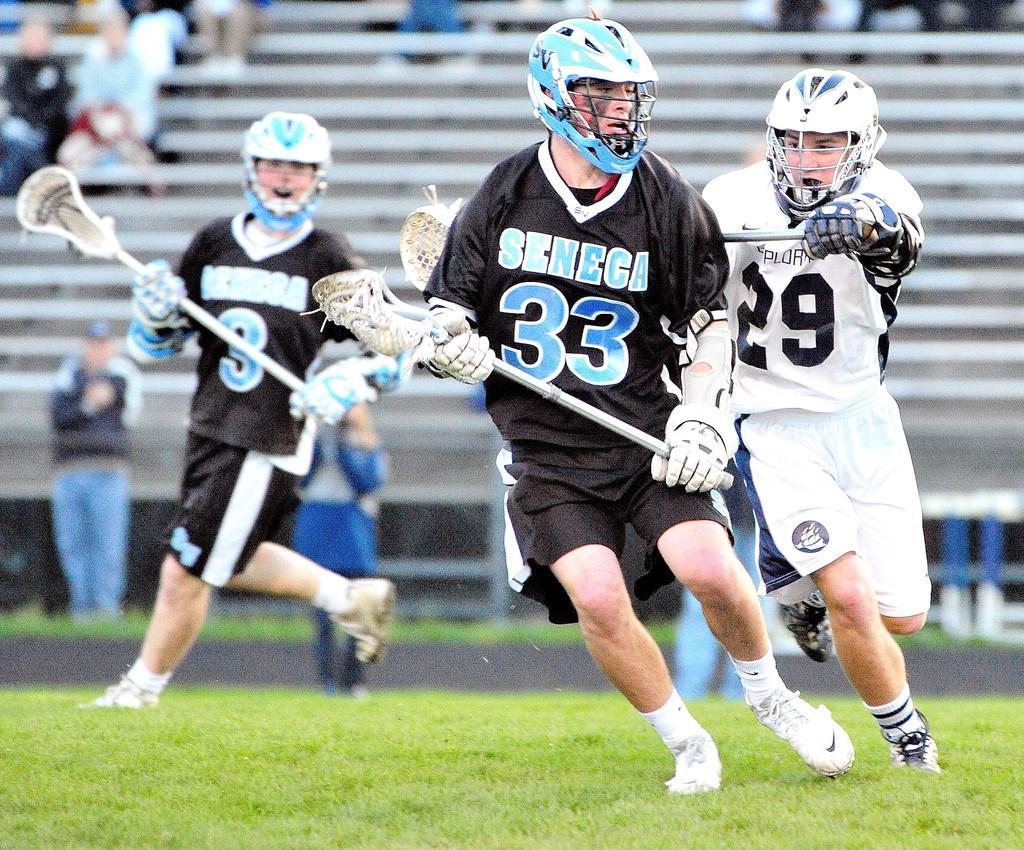Please provide a concise description of this image. In this image I can see an open grass ground and on it I can see three persons are standing. I can also see all of them are wearing gloves, helmets and sports jerseys. I can also see they all are holding sticks and on their jerseys I can see something is written. In the background I can see people where few are standing and rest all are sitting. I can also see this image is little bit blurry in the background. 